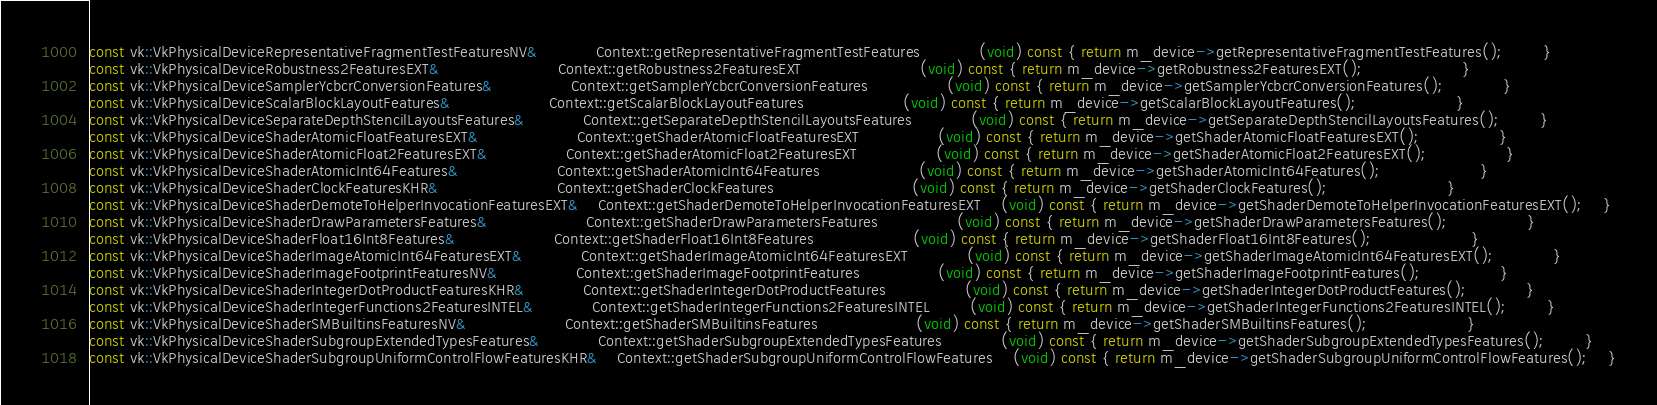Convert code to text. <code><loc_0><loc_0><loc_500><loc_500><_C++_>const vk::VkPhysicalDeviceRepresentativeFragmentTestFeaturesNV&			Context::getRepresentativeFragmentTestFeatures			(void) const { return m_device->getRepresentativeFragmentTestFeatures();		}
const vk::VkPhysicalDeviceRobustness2FeaturesEXT&						Context::getRobustness2FeaturesEXT						(void) const { return m_device->getRobustness2FeaturesEXT();					}
const vk::VkPhysicalDeviceSamplerYcbcrConversionFeatures&				Context::getSamplerYcbcrConversionFeatures				(void) const { return m_device->getSamplerYcbcrConversionFeatures();			}
const vk::VkPhysicalDeviceScalarBlockLayoutFeatures&					Context::getScalarBlockLayoutFeatures					(void) const { return m_device->getScalarBlockLayoutFeatures();					}
const vk::VkPhysicalDeviceSeparateDepthStencilLayoutsFeatures&			Context::getSeparateDepthStencilLayoutsFeatures			(void) const { return m_device->getSeparateDepthStencilLayoutsFeatures();		}
const vk::VkPhysicalDeviceShaderAtomicFloatFeaturesEXT&					Context::getShaderAtomicFloatFeaturesEXT				(void) const { return m_device->getShaderAtomicFloatFeaturesEXT();				}
const vk::VkPhysicalDeviceShaderAtomicFloat2FeaturesEXT&				Context::getShaderAtomicFloat2FeaturesEXT				(void) const { return m_device->getShaderAtomicFloat2FeaturesEXT();				}
const vk::VkPhysicalDeviceShaderAtomicInt64Features&					Context::getShaderAtomicInt64Features					(void) const { return m_device->getShaderAtomicInt64Features();					}
const vk::VkPhysicalDeviceShaderClockFeaturesKHR&						Context::getShaderClockFeatures							(void) const { return m_device->getShaderClockFeatures();						}
const vk::VkPhysicalDeviceShaderDemoteToHelperInvocationFeaturesEXT&	Context::getShaderDemoteToHelperInvocationFeaturesEXT	(void) const { return m_device->getShaderDemoteToHelperInvocationFeaturesEXT();	}
const vk::VkPhysicalDeviceShaderDrawParametersFeatures&					Context::getShaderDrawParametersFeatures				(void) const { return m_device->getShaderDrawParametersFeatures();				}
const vk::VkPhysicalDeviceShaderFloat16Int8Features&					Context::getShaderFloat16Int8Features					(void) const { return m_device->getShaderFloat16Int8Features();					}
const vk::VkPhysicalDeviceShaderImageAtomicInt64FeaturesEXT&			Context::getShaderImageAtomicInt64FeaturesEXT			(void) const { return m_device->getShaderImageAtomicInt64FeaturesEXT();			}
const vk::VkPhysicalDeviceShaderImageFootprintFeaturesNV&				Context::getShaderImageFootprintFeatures				(void) const { return m_device->getShaderImageFootprintFeatures();				}
const vk::VkPhysicalDeviceShaderIntegerDotProductFeaturesKHR&			Context::getShaderIntegerDotProductFeatures				(void) const { return m_device->getShaderIntegerDotProductFeatures();			}
const vk::VkPhysicalDeviceShaderIntegerFunctions2FeaturesINTEL&			Context::getShaderIntegerFunctions2FeaturesINTEL		(void) const { return m_device->getShaderIntegerFunctions2FeaturesINTEL();		}
const vk::VkPhysicalDeviceShaderSMBuiltinsFeaturesNV&					Context::getShaderSMBuiltinsFeatures					(void) const { return m_device->getShaderSMBuiltinsFeatures();					}
const vk::VkPhysicalDeviceShaderSubgroupExtendedTypesFeatures&			Context::getShaderSubgroupExtendedTypesFeatures			(void) const { return m_device->getShaderSubgroupExtendedTypesFeatures();		}
const vk::VkPhysicalDeviceShaderSubgroupUniformControlFlowFeaturesKHR&	Context::getShaderSubgroupUniformControlFlowFeatures	(void) const { return m_device->getShaderSubgroupUniformControlFlowFeatures();	}</code> 